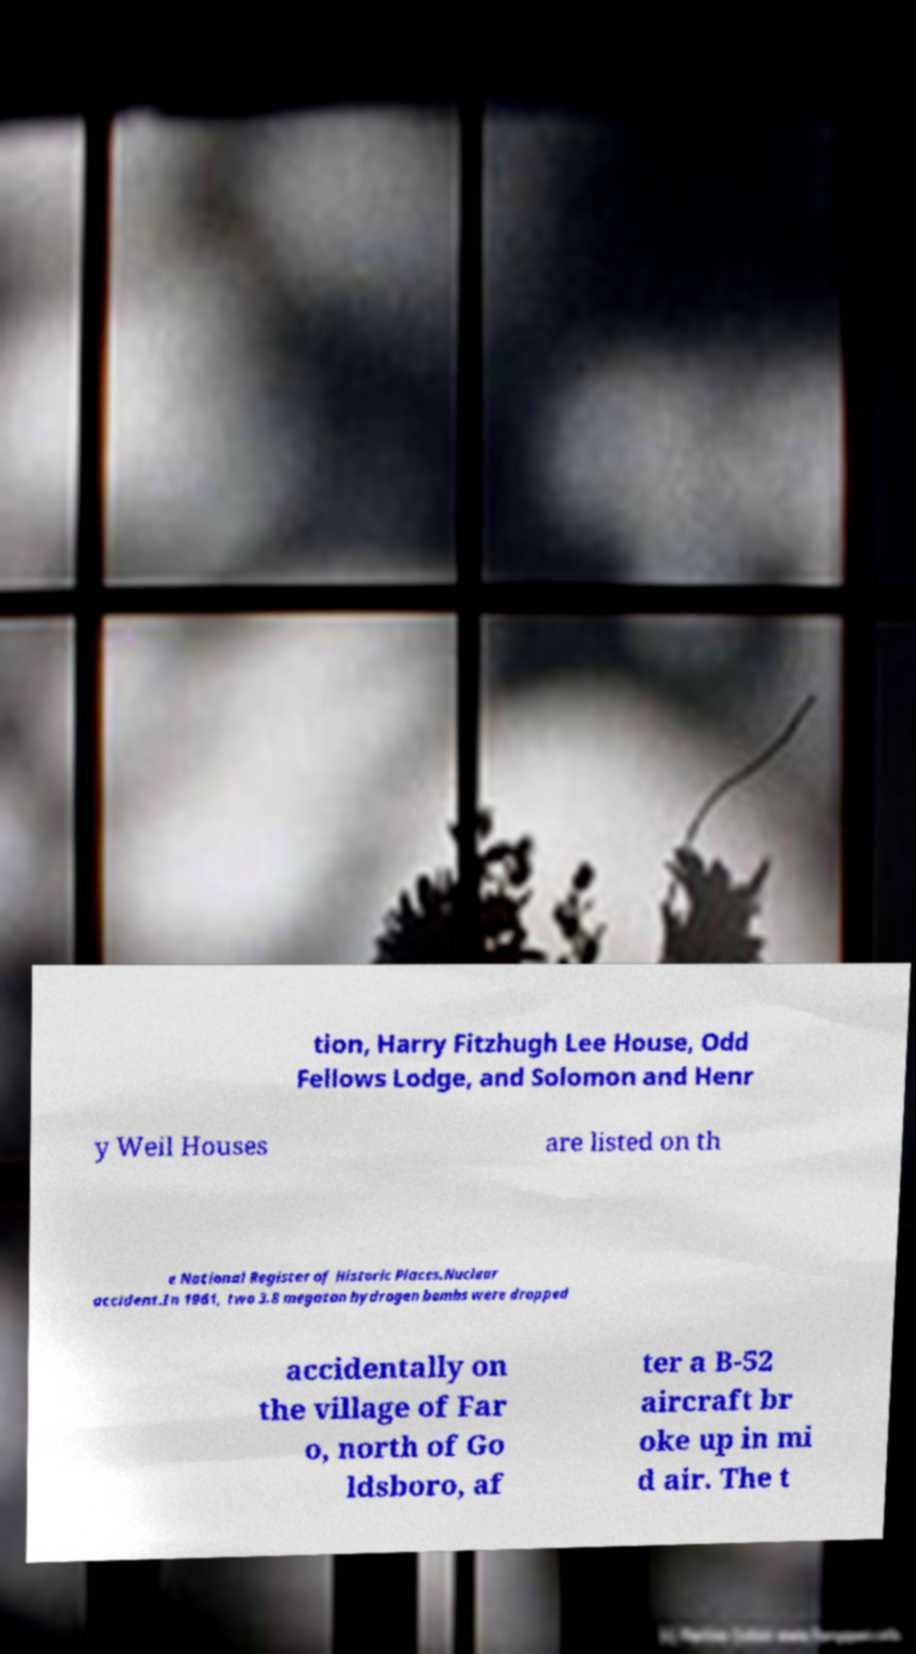For documentation purposes, I need the text within this image transcribed. Could you provide that? tion, Harry Fitzhugh Lee House, Odd Fellows Lodge, and Solomon and Henr y Weil Houses are listed on th e National Register of Historic Places.Nuclear accident.In 1961, two 3.8 megaton hydrogen bombs were dropped accidentally on the village of Far o, north of Go ldsboro, af ter a B-52 aircraft br oke up in mi d air. The t 